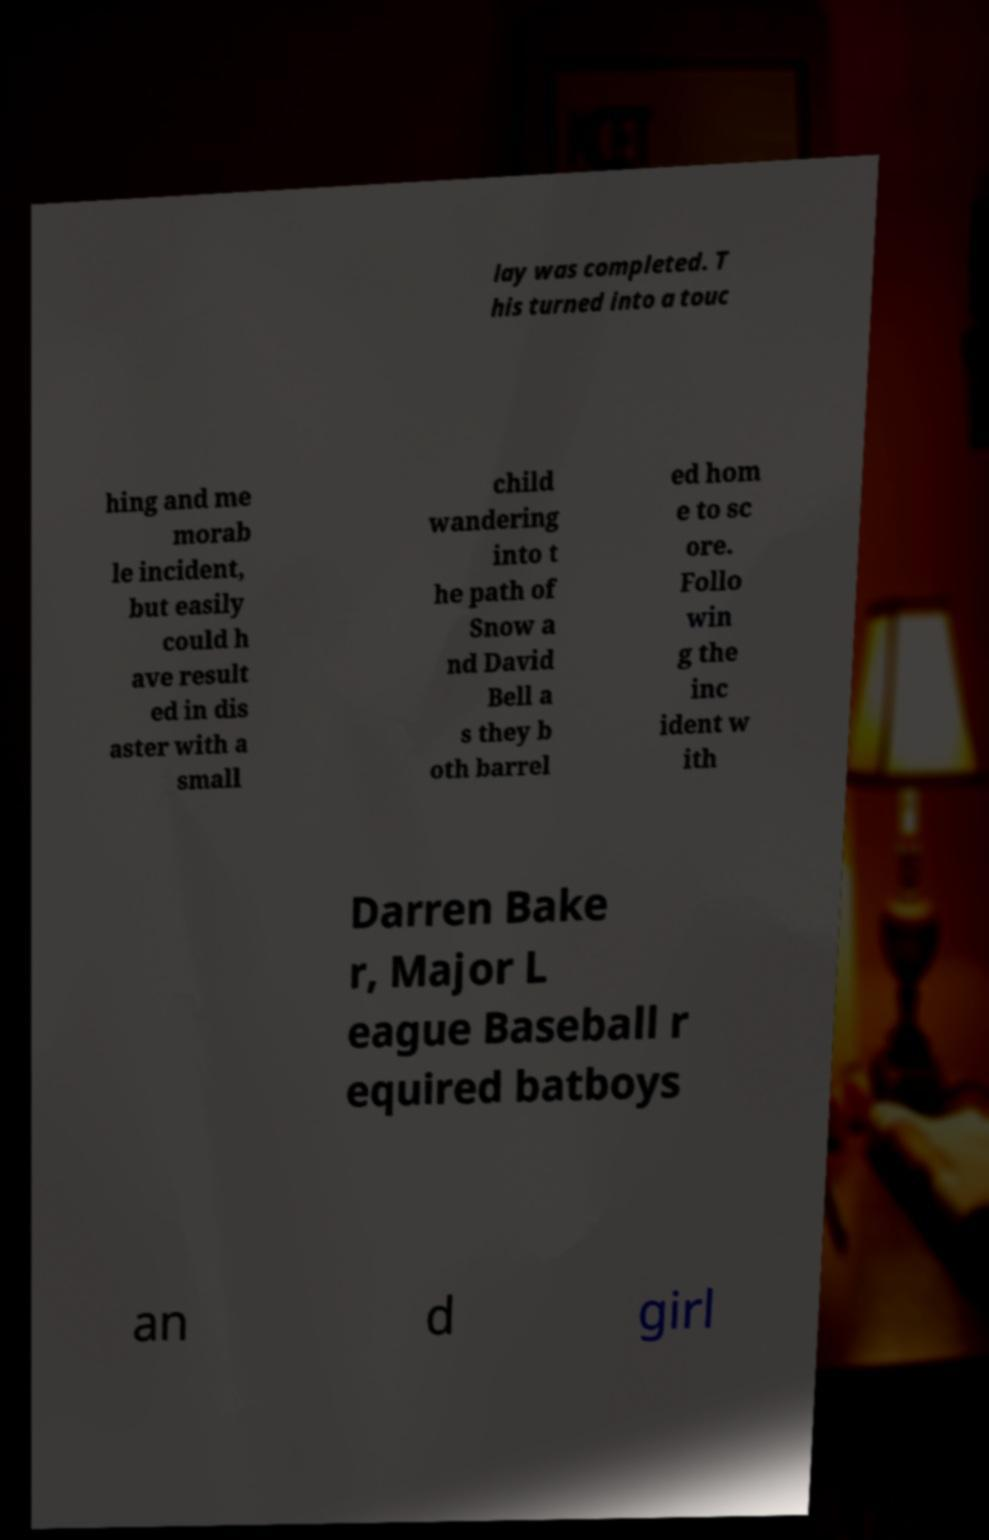What messages or text are displayed in this image? I need them in a readable, typed format. lay was completed. T his turned into a touc hing and me morab le incident, but easily could h ave result ed in dis aster with a small child wandering into t he path of Snow a nd David Bell a s they b oth barrel ed hom e to sc ore. Follo win g the inc ident w ith Darren Bake r, Major L eague Baseball r equired batboys an d girl 